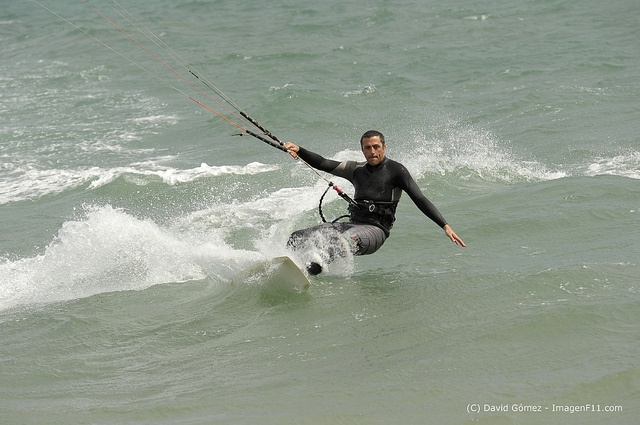Describe the objects in this image and their specific colors. I can see people in gray, black, darkgray, and lightgray tones and surfboard in gray and darkgray tones in this image. 